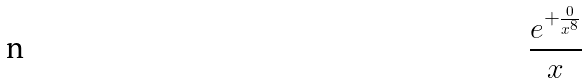<formula> <loc_0><loc_0><loc_500><loc_500>\frac { e ^ { + \frac { 0 } { x ^ { 8 } } } } { x }</formula> 